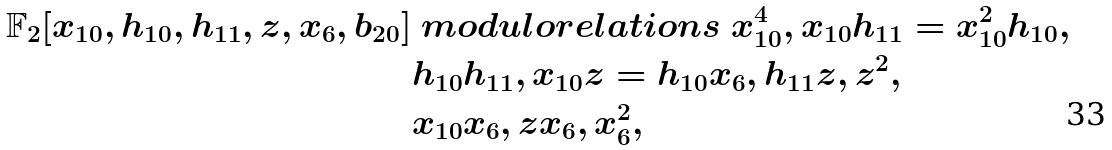<formula> <loc_0><loc_0><loc_500><loc_500>\mathbb { F } _ { 2 } [ x _ { 1 0 } , h _ { 1 0 } , h _ { 1 1 } , z , x _ { 6 } , b _ { 2 0 } ] & \ m o d u l o r e l a t i o n s \ x _ { 1 0 } ^ { 4 } , x _ { 1 0 } h _ { 1 1 } = x _ { 1 0 } ^ { 2 } h _ { 1 0 } , \\ & h _ { 1 0 } h _ { 1 1 } , x _ { 1 0 } z = h _ { 1 0 } x _ { 6 } , h _ { 1 1 } z , z ^ { 2 } , \\ & x _ { 1 0 } x _ { 6 } , z x _ { 6 } , x _ { 6 } ^ { 2 } ,</formula> 